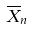<formula> <loc_0><loc_0><loc_500><loc_500>\overline { X } _ { n }</formula> 